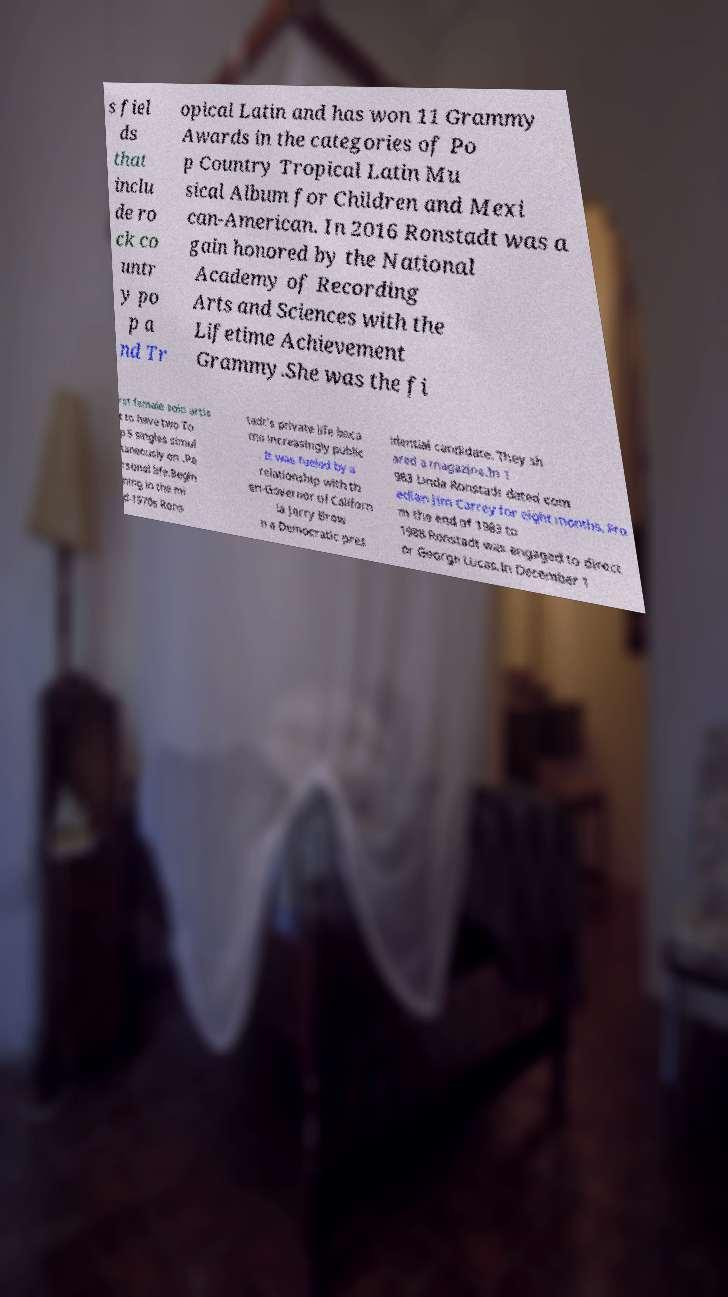Can you accurately transcribe the text from the provided image for me? s fiel ds that inclu de ro ck co untr y po p a nd Tr opical Latin and has won 11 Grammy Awards in the categories of Po p Country Tropical Latin Mu sical Album for Children and Mexi can-American. In 2016 Ronstadt was a gain honored by the National Academy of Recording Arts and Sciences with the Lifetime Achievement Grammy.She was the fi rst female solo artis t to have two To p 5 singles simul taneously on .Pe rsonal life.Begin ning in the mi d-1970s Rons tadt's private life beca me increasingly public . It was fueled by a relationship with th en-Governor of Californ ia Jerry Brow n a Democratic pres idential candidate. They sh ared a magazine.In 1 983 Linda Ronstadt dated com edian Jim Carrey for eight months. Fro m the end of 1983 to 1988 Ronstadt was engaged to direct or George Lucas.In December 1 